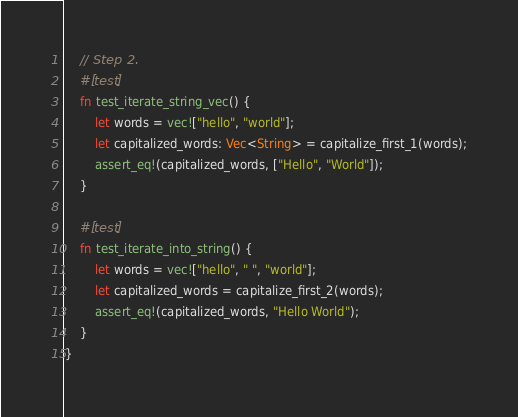<code> <loc_0><loc_0><loc_500><loc_500><_Rust_>    // Step 2.
    #[test]
    fn test_iterate_string_vec() {
        let words = vec!["hello", "world"];
        let capitalized_words: Vec<String> = capitalize_first_1(words);
        assert_eq!(capitalized_words, ["Hello", "World"]);
    }

    #[test]
    fn test_iterate_into_string() {
        let words = vec!["hello", " ", "world"];
        let capitalized_words = capitalize_first_2(words);
        assert_eq!(capitalized_words, "Hello World");
    }
}
</code> 